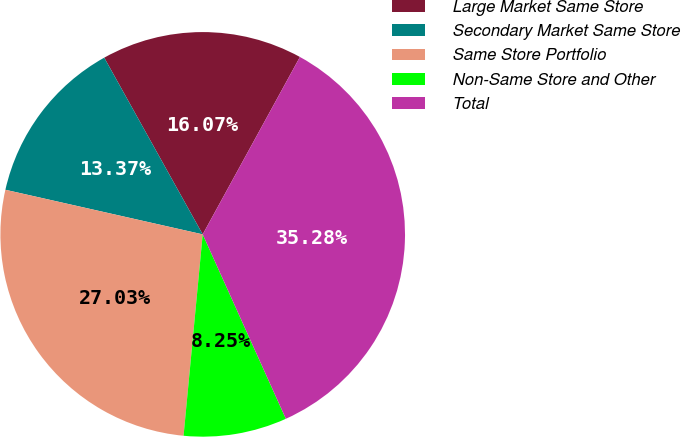Convert chart. <chart><loc_0><loc_0><loc_500><loc_500><pie_chart><fcel>Large Market Same Store<fcel>Secondary Market Same Store<fcel>Same Store Portfolio<fcel>Non-Same Store and Other<fcel>Total<nl><fcel>16.07%<fcel>13.37%<fcel>27.03%<fcel>8.25%<fcel>35.28%<nl></chart> 